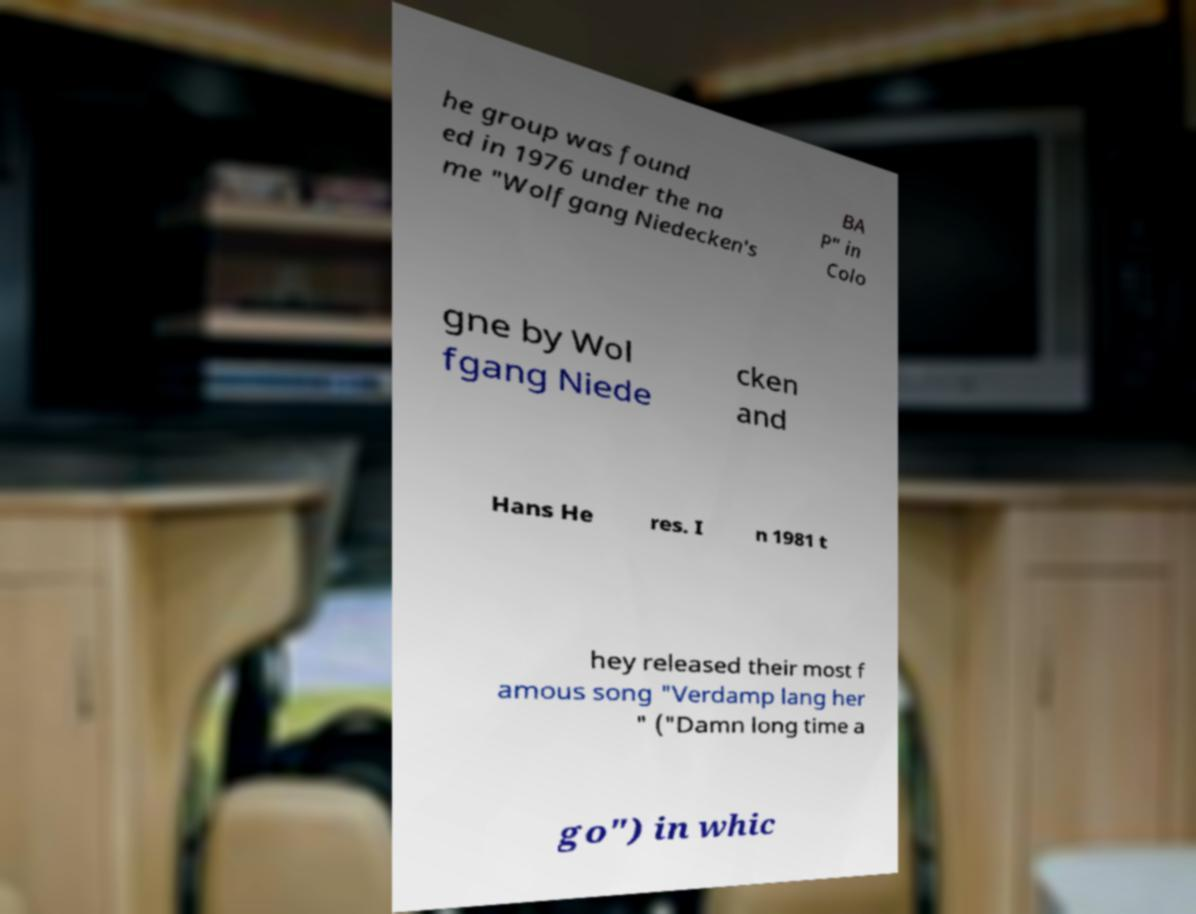There's text embedded in this image that I need extracted. Can you transcribe it verbatim? he group was found ed in 1976 under the na me "Wolfgang Niedecken's BA P" in Colo gne by Wol fgang Niede cken and Hans He res. I n 1981 t hey released their most f amous song "Verdamp lang her " ("Damn long time a go") in whic 